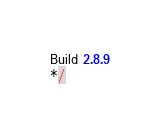<code> <loc_0><loc_0><loc_500><loc_500><_JavaScript_>
Build 2.8.9
*/</code> 